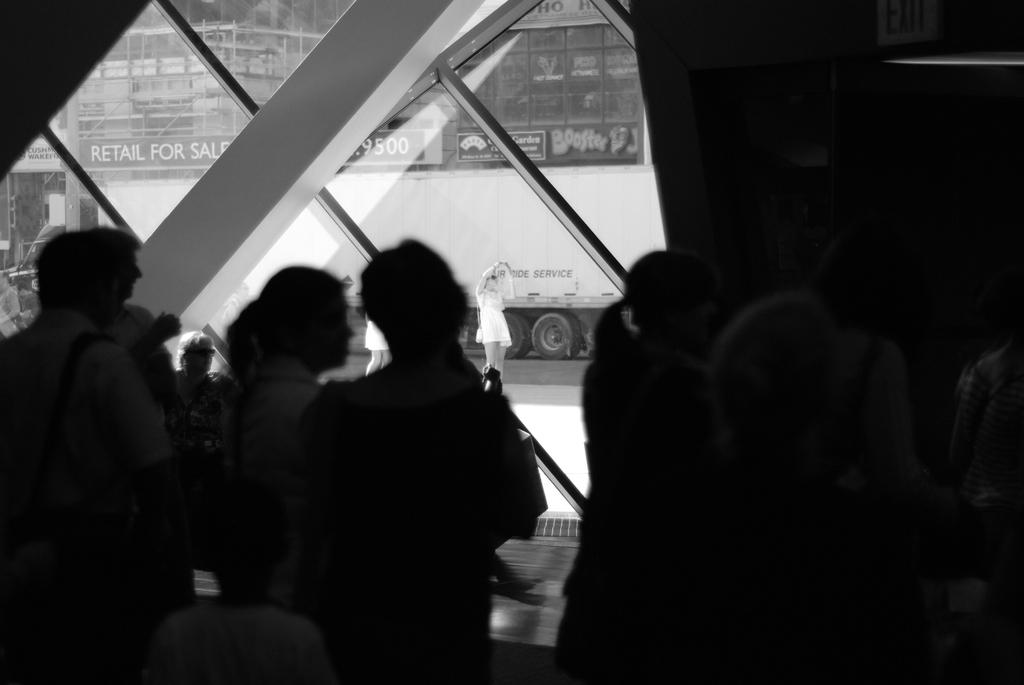What is the color scheme of the image? The image is black and white. What are the persons in the foreground doing? The persons in the foreground are standing at the window. What can be seen in the background of the image? In the background, there are persons visible, a vehicle, a road, and buildings. What type of maid is visible in the image? There is no maid present in the image. What kind of growth can be seen on the persons in the image? There is no growth visible on the persons in the image, as it is a black and white photograph. 